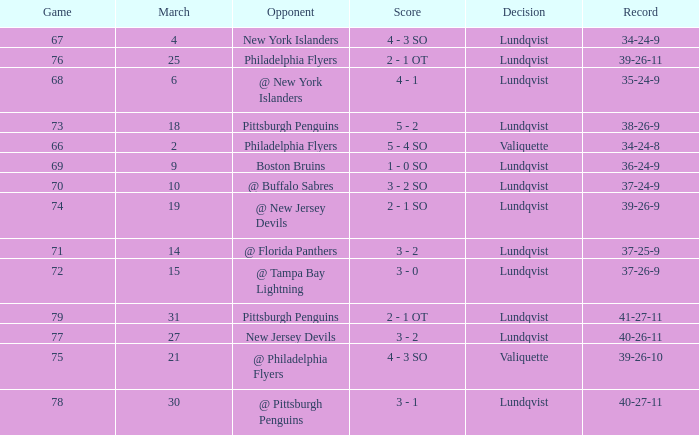Which opponent's march was 31? Pittsburgh Penguins. 